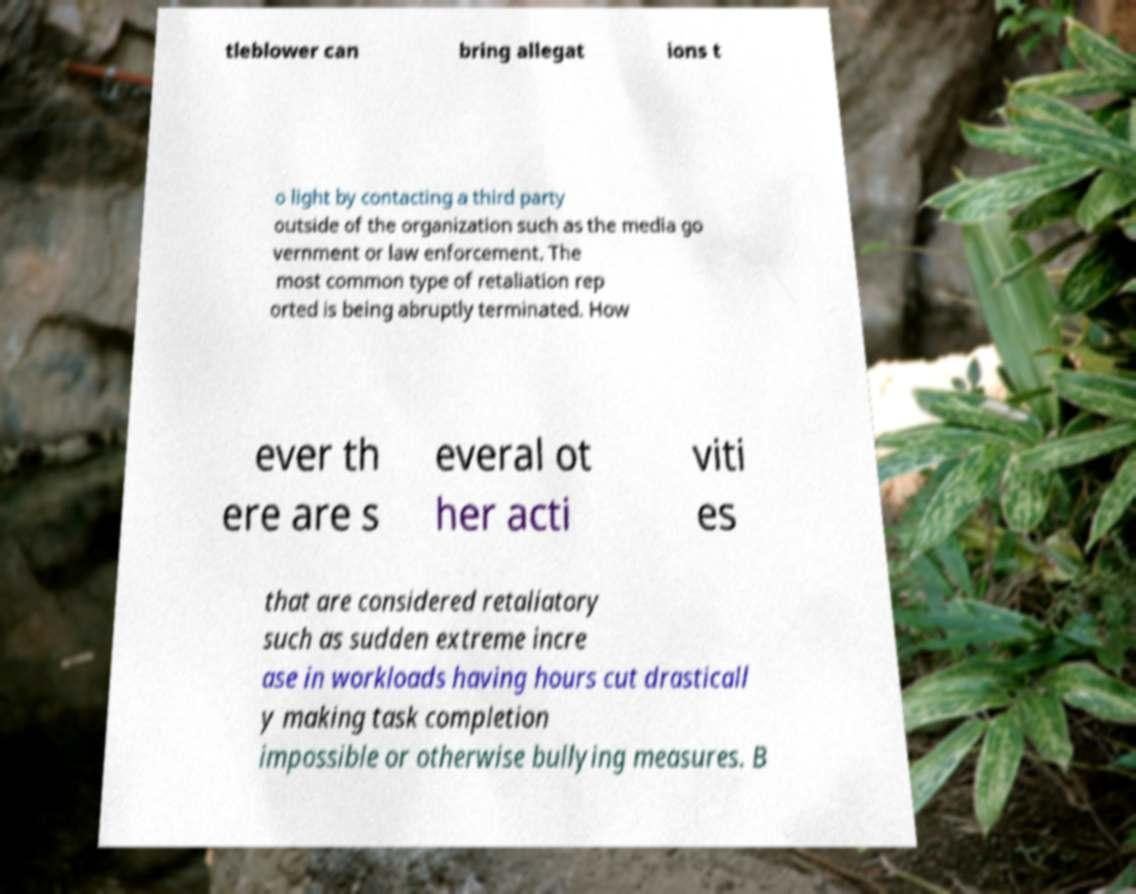Please identify and transcribe the text found in this image. tleblower can bring allegat ions t o light by contacting a third party outside of the organization such as the media go vernment or law enforcement. The most common type of retaliation rep orted is being abruptly terminated. How ever th ere are s everal ot her acti viti es that are considered retaliatory such as sudden extreme incre ase in workloads having hours cut drasticall y making task completion impossible or otherwise bullying measures. B 